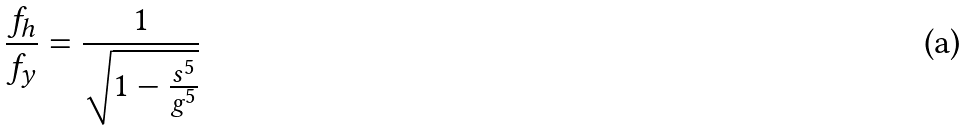Convert formula to latex. <formula><loc_0><loc_0><loc_500><loc_500>\frac { f _ { h } } { f _ { y } } = \frac { 1 } { \sqrt { 1 - \frac { s ^ { 5 } } { g ^ { 5 } } } }</formula> 